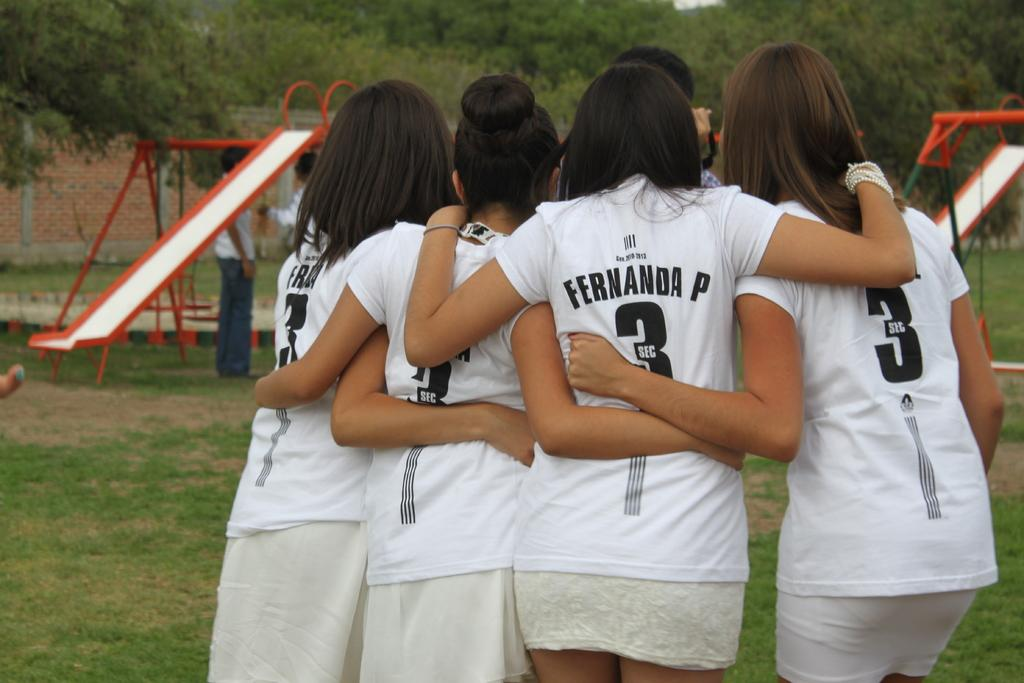Provide a one-sentence caption for the provided image. a few teammates and one with the number 3 on. 